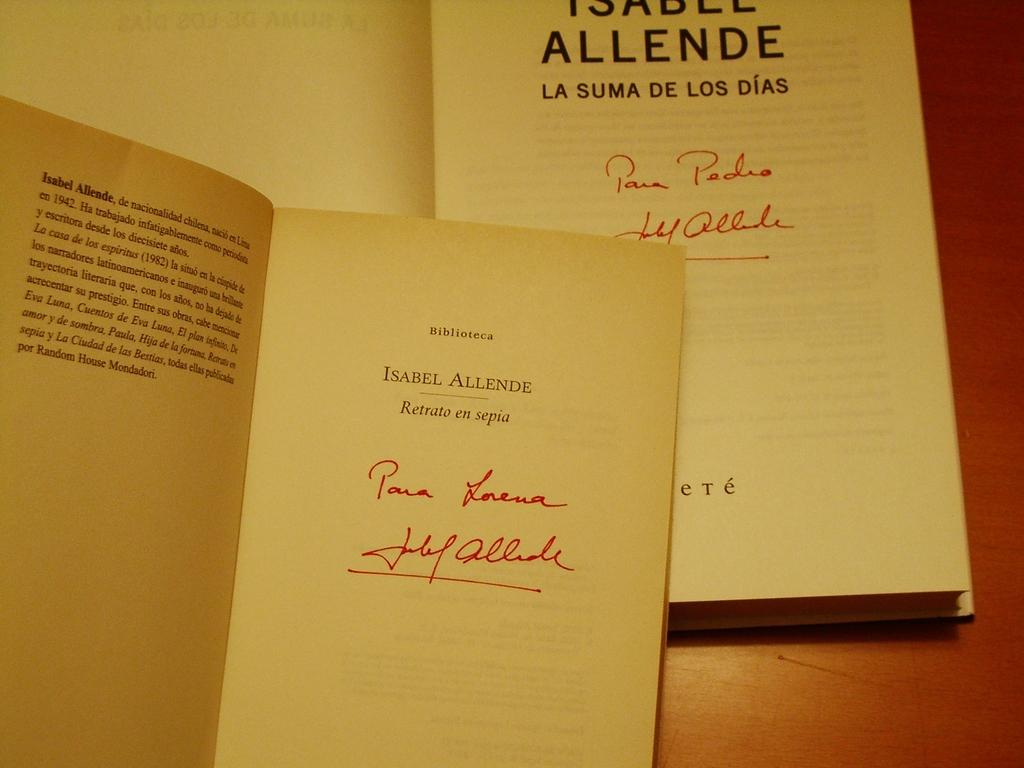<image>
Share a concise interpretation of the image provided. a couple of open books that say 'biblioteca and isabel allende" on it 